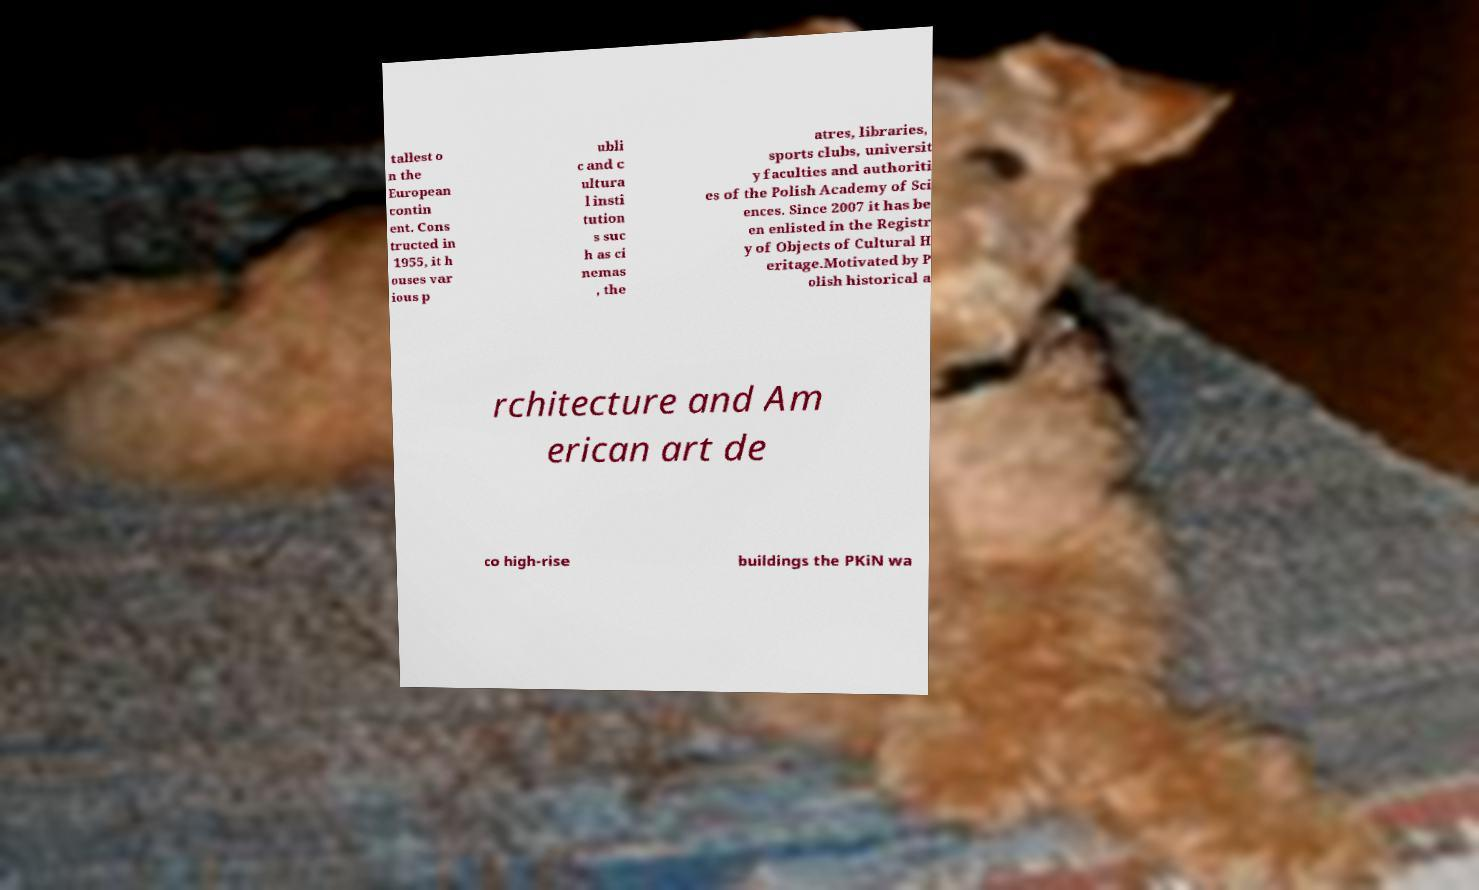Please read and relay the text visible in this image. What does it say? tallest o n the European contin ent. Cons tructed in 1955, it h ouses var ious p ubli c and c ultura l insti tution s suc h as ci nemas , the atres, libraries, sports clubs, universit y faculties and authoriti es of the Polish Academy of Sci ences. Since 2007 it has be en enlisted in the Registr y of Objects of Cultural H eritage.Motivated by P olish historical a rchitecture and Am erican art de co high-rise buildings the PKiN wa 